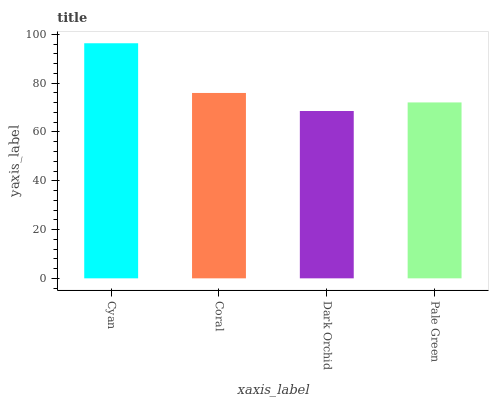Is Dark Orchid the minimum?
Answer yes or no. Yes. Is Cyan the maximum?
Answer yes or no. Yes. Is Coral the minimum?
Answer yes or no. No. Is Coral the maximum?
Answer yes or no. No. Is Cyan greater than Coral?
Answer yes or no. Yes. Is Coral less than Cyan?
Answer yes or no. Yes. Is Coral greater than Cyan?
Answer yes or no. No. Is Cyan less than Coral?
Answer yes or no. No. Is Coral the high median?
Answer yes or no. Yes. Is Pale Green the low median?
Answer yes or no. Yes. Is Dark Orchid the high median?
Answer yes or no. No. Is Dark Orchid the low median?
Answer yes or no. No. 